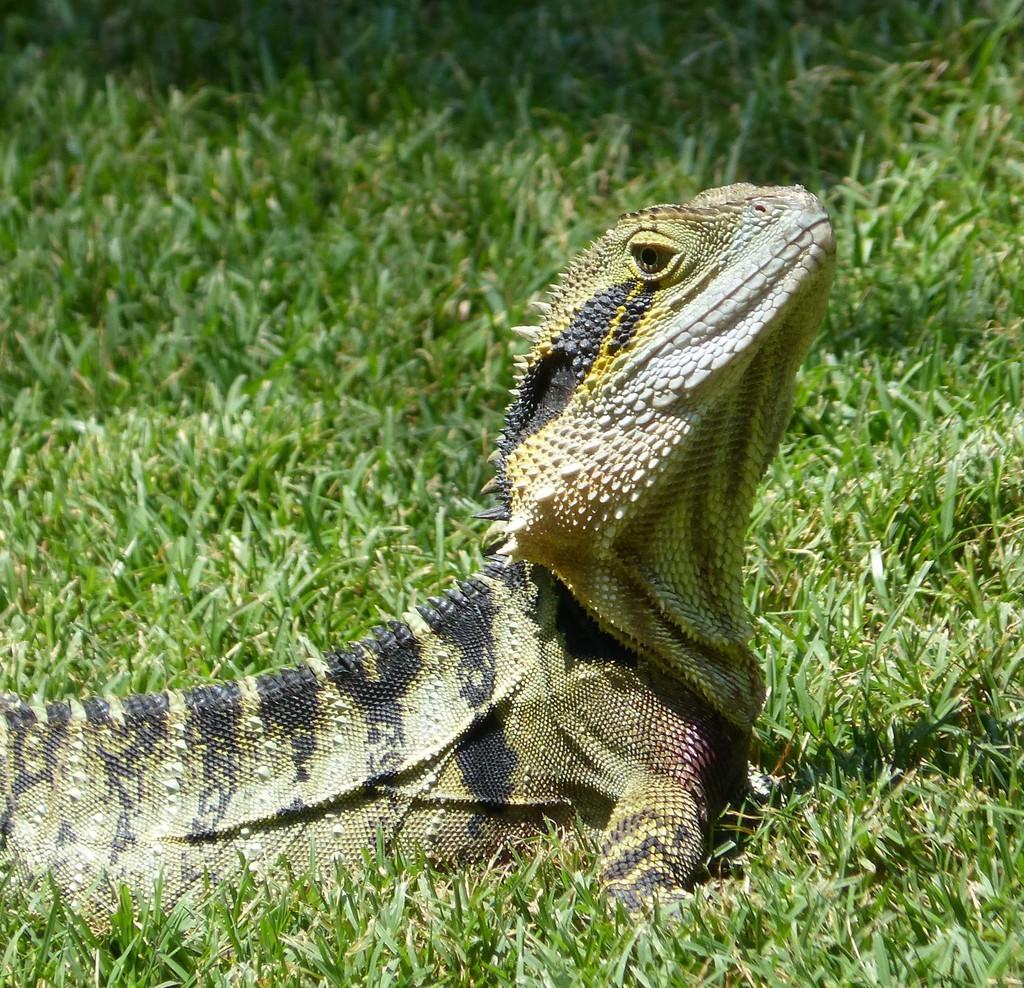Can you describe this image briefly? In the center of the image we can see a dragon lizard. In the background of the image we can see the grass. 